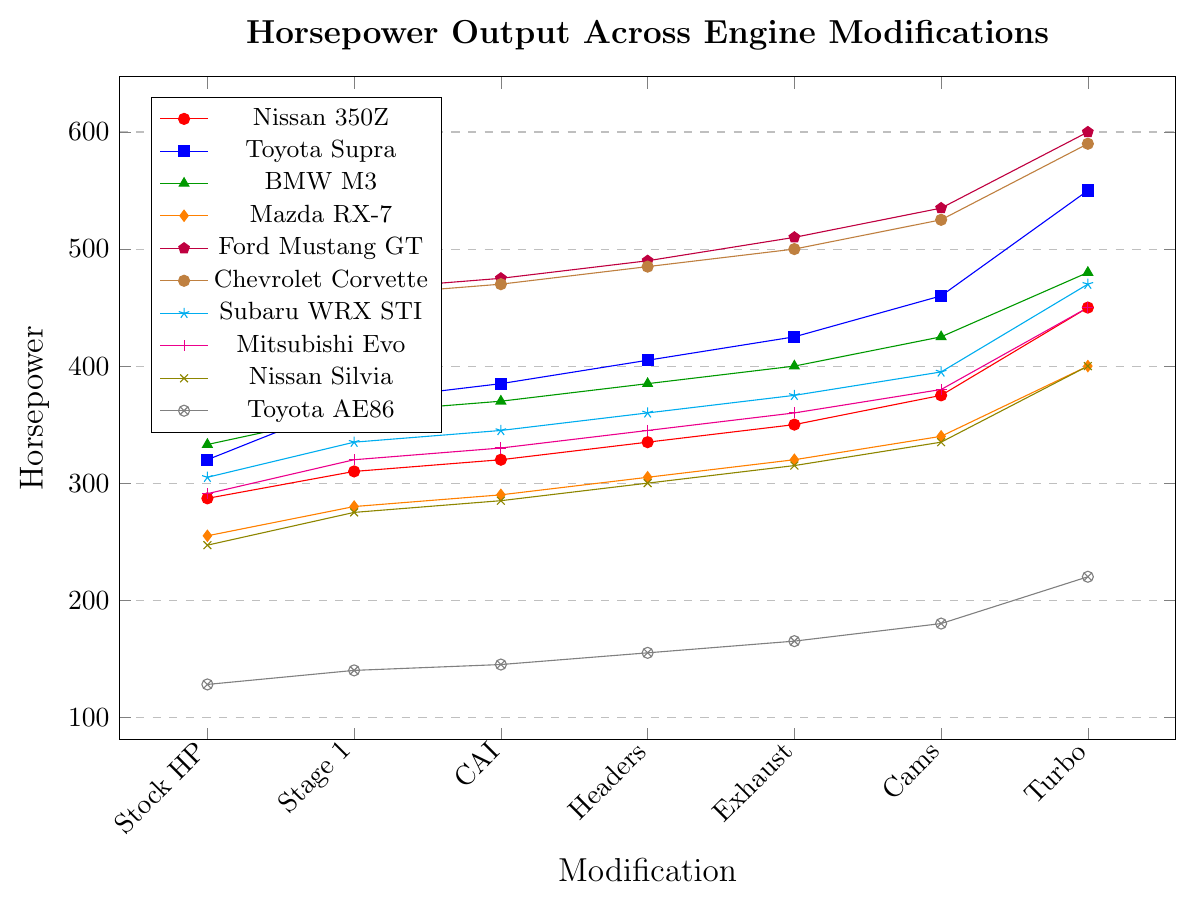Which modification results in the highest horsepower increase for the Nissan Silvia? First, note the horsepower for the Nissan Silvia at stock (247) and after each modification: Stage 1 (275), CAI (285), Headers (300), Exhaust (315), Cams (335), and Turbo (400). The largest increase is from Cams (335) to Turbo (400), which is 65.
Answer: Turbo Among all the cars, which model exhibits the highest horsepower with a turbo upgrade? Identify the horsepower figures for each vehicle after the Turbo Upgrade: Nissan 350Z (450), Toyota Supra (550), BMW M3 (480), Mazda RX-7 (400), Ford Mustang GT (600), Chevrolet Corvette (590), Subaru WRX STI (470), Mitsubishi Evo (450), Nissan Silvia (400), Toyota AE86 (220). The Ford Mustang GT has the highest value, 600.
Answer: Ford Mustang GT How much total horsepower gain does the Chevrolet Corvette achieve from stock to all modifications combined? Calculate the horsepower gain at each step: Stage 1 (460-430=30), CAI (470-460=10), Headers (485-470=15), Exhaust (500-485=15), Cams (525-500=25), Turbo (590-525=65). Sum these differences: 30 + 10 + 15 + 15 + 25 + 65 = 160.
Answer: 160 Which car shows the smallest initial gain (from stock to Stage 1)? Subtract the stock horsepower from the Stage 1 horsepower for each car: Nissan 350Z (310-287=23), Toyota Supra (370-320=50), BMW M3 (360-333=27), Mazda RX-7 (280-255=25), Ford Mustang GT (465-435=30), Chevrolet Corvette (460-430=30), Subaru WRX STI (335-305=30), Mitsubishi Evo (320-291=29), Nissan Silvia (275-247=28), Toyota AE86 (140-128=12). The Toyota AE86 shows the smallest gain of 12.
Answer: Toyota AE86 Between the Toyota Supra and Mazda RX-7, which car has a greater increase in horsepower from Headers to Exhaust? For the Toyota Supra, Headers to Exhaust is 425 - 405 = 20. For the Mazda RX-7, Headers to Exhaust is 320 - 305 = 15. Therefore, the Toyota Supra has a greater increase of 20.
Answer: Toyota Supra Which model demonstrates the second highest horsepower with camshafts modification? Identify the horsepower for each model with camshafts: Nissan 350Z (375), Toyota Supra (460), BMW M3 (425), Mazda RX-7 (340), Ford Mustang GT (535), Chevrolet Corvette (525), Subaru WRX STI (395), Mitsubishi Evo (380), Nissan Silvia (335), Toyota AE86 (180). The second highest value is 525 for the Chevrolet Corvette.
Answer: Chevrolet Corvette How does the horsepower of the Mazda RX-7 with an Exhaust modification compare to the BMW M3 with Headers? The horsepower of the Mazda RX-7 with Exhaust is 320. The horsepower of the BMW M3 with Headers is 385. The BMW M3 with Headers has higher horsepower.
Answer: BMW M3 If you want an average horsepower increase across all modifications for the Toyota AE86, what would it be? Calculate the increase at each step: Stage 1 (140-128=12), CAI (145-140=5), Headers (155-145=10), Exhaust (165-155=10), Cams (180-165=15), Turbo (220-180=40). Sum these differences: 12+5+10+10+15+40 = 92. Average = 92/6 = 15.33.
Answer: 15.33 